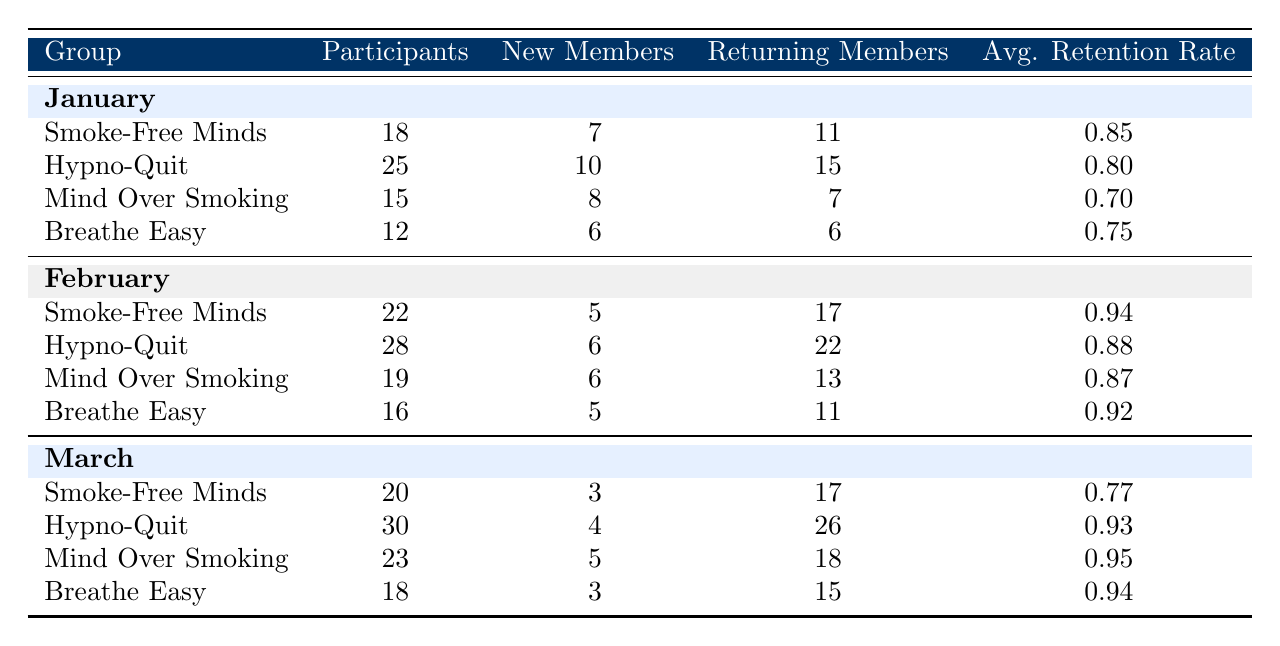What was the highest number of participants in a single month across all groups? The maximum value in the Participants column is 30, which is in March for the Hypno-Quit group.
Answer: 30 Which group had the lowest average retention rate? By looking at the Avg. Retention Rate column, Mind Over Smoking has the lowest rate at 0.70 in January.
Answer: 0.70 How many new members joined the Smoke-Free Minds group in total over the three months? Adding the New Members for Smoke-Free Minds across January (7), February (5), and March (3) gives 7 + 5 + 3 = 15.
Answer: 15 Did Breathe Easy have more returning members than new members in all three months? Checking each month: In January, returning members (6) equals new members (6), in February returning (11) is greater than new (5), and in March returning (15) is greater than new (3). The statement is true for February and March but not for January.
Answer: No What was the total number of participants for Hypno-Quit over the three months? Summing the participants: January (25), February (28), and March (30) results in 25 + 28 + 30 = 83.
Answer: 83 Which month had the highest average retention rate across all groups? To find this, calculate the average retention rate for each month: January average is (0.85 + 0.80 + 0.70 + 0.75) / 4 = 0.775, February is (0.94 + 0.88 + 0.87 + 0.92) / 4 = 0.9125, and March is (0.77 + 0.93 + 0.95 + 0.94) / 4 = 0.8975. February has the highest average.
Answer: February How many total new members joined the Mind Over Smoking group in the first quarter? Adding new members from January (8), February (6), and March (5) gives 8 + 6 + 5 = 19.
Answer: 19 Did any group consistently have a retention rate above 0.90 in each month? Examining each group's average retention rate: Hypno-Quit had rates of 0.80, 0.88, and 0.93. While Mind Over Smoking had 0.70, 0.87, and 0.95, which also doesn’t meet the requirement. Therefore, no group consistently maintained a retention rate above 0.90.
Answer: No 